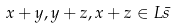<formula> <loc_0><loc_0><loc_500><loc_500>x + y , y + z , x + z \in L { \bar { s } }</formula> 